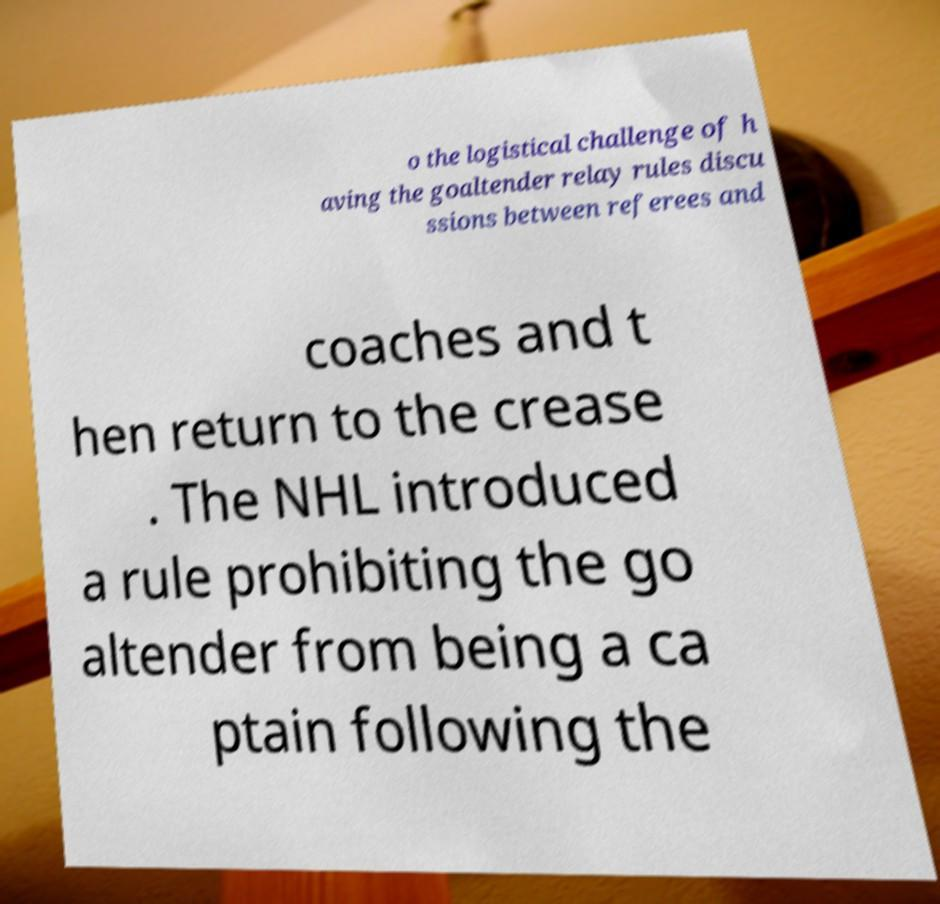There's text embedded in this image that I need extracted. Can you transcribe it verbatim? o the logistical challenge of h aving the goaltender relay rules discu ssions between referees and coaches and t hen return to the crease . The NHL introduced a rule prohibiting the go altender from being a ca ptain following the 